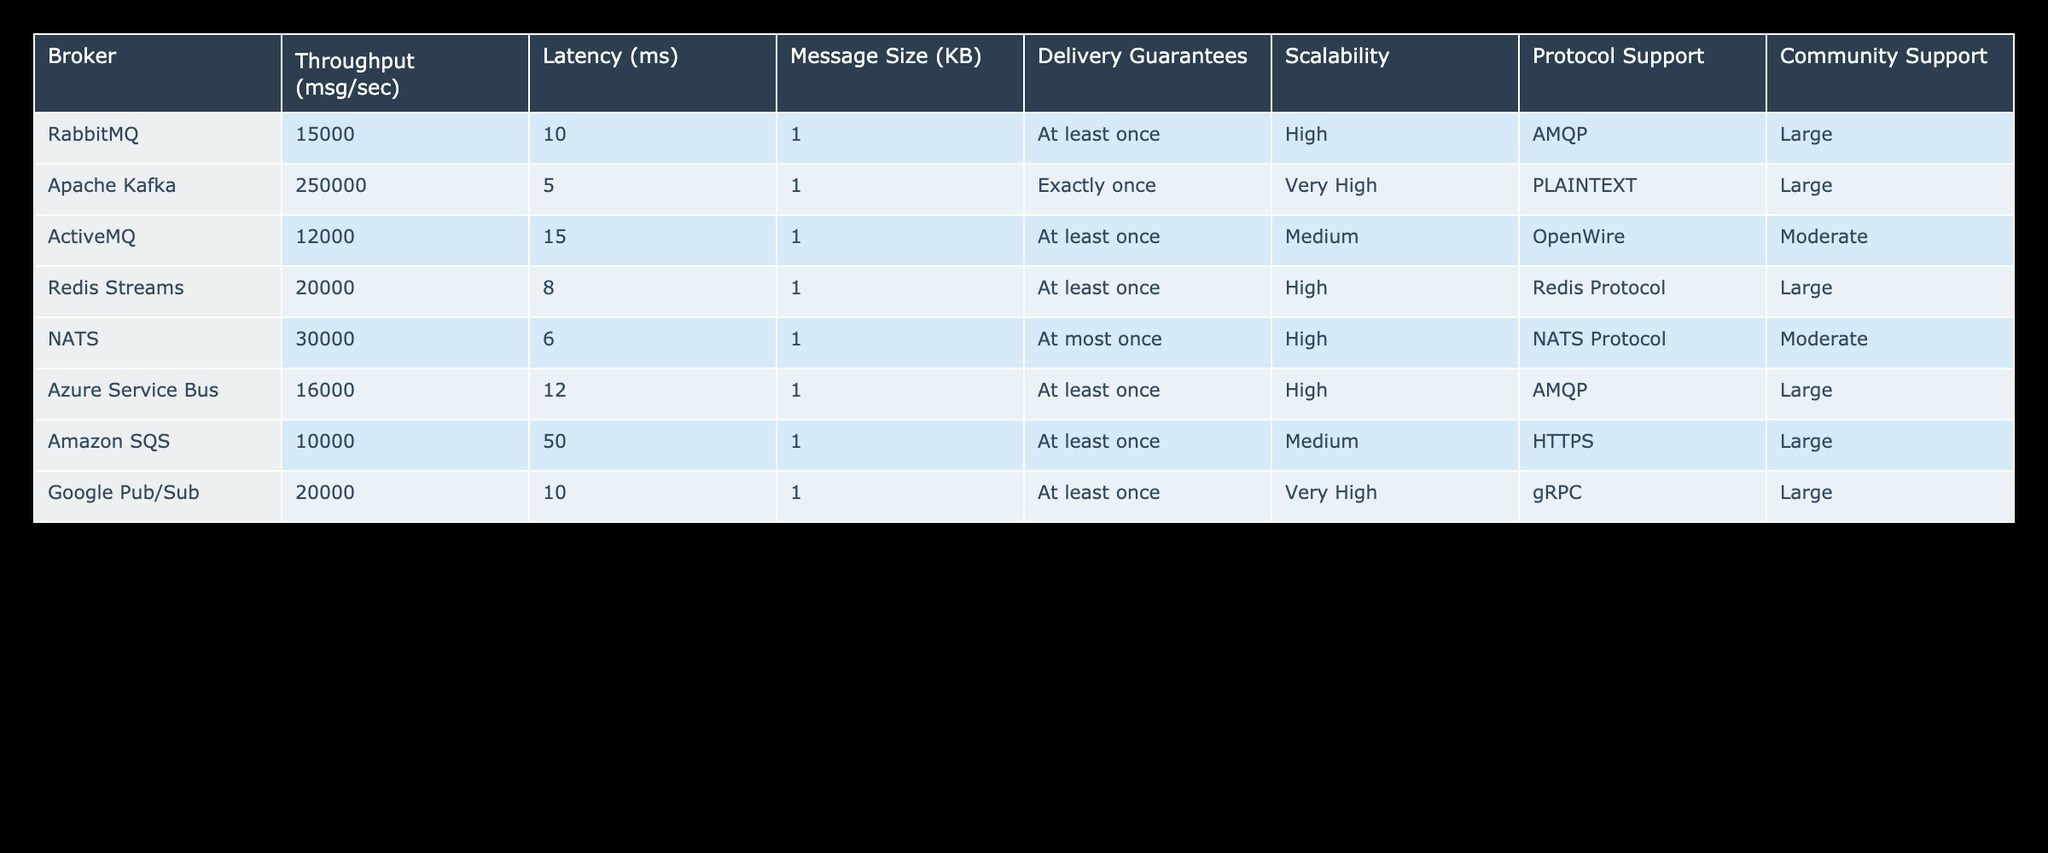What is the throughput of Apache Kafka? The table shows that the throughput for Apache Kafka is listed under the "Throughput (msg/sec)" column, and the respective value is 250000 messages per second.
Answer: 250000 Which broker has the lowest latency? By inspecting the "Latency (ms)" column in the table, we can see that NATS has the lowest latency at 6 milliseconds when compared to other brokers.
Answer: 6 ms What is the average throughput of all brokers listed? First, we add the throughput values: 15000 + 250000 + 12000 + 20000 + 30000 + 16000 + 10000 + 20000 = 266000. Then, we divide by the number of brokers (8) to find the average: 266000 / 8 = 33250.
Answer: 33250 Does Google Pub/Sub support exactly-once delivery guarantees? Looking at the "Delivery Guarantees" column for Google Pub/Sub, it states "At least once", which indicates that it does not support exactly-once delivery guarantees.
Answer: No Which broker exhibits the highest scalability? The "Scalability" column indicates levels of scalability, where Apache Kafka is labeled with "Very High," which is the highest categorization in the table.
Answer: Very High How much higher is the throughput of Apache Kafka compared to RabbitMQ? Apache Kafka's throughput is 250000, while RabbitMQ's throughput is 15000. To find the difference, we calculate: 250000 - 15000 = 235000.
Answer: 235000 Is Redis Streams community support moderate or large? Checking the "Community Support" column, Redis Streams has "Large" community support, indicating a strong backing from the user community.
Answer: Large What is the average latency of brokers that offer "At least once" delivery guarantees? The brokers with "At least once" guarantees are RabbitMQ, ActiveMQ, Redis Streams, Azure Service Bus, and Amazon SQS, with latency values of 10, 15, 8, 12, and 50 ms respectively. The average is: (10 + 15 + 8 + 12 + 50) / 5 = 95 / 5 = 19.
Answer: 19 ms Which broker has both very high scalability and support for exact once delivery guarantees? Observing the table, Apache Kafka is the only broker that has "Very High" scalability while simultaneously having "Exactly once" delivery guarantees, making it unique in this respect.
Answer: Apache Kafka 